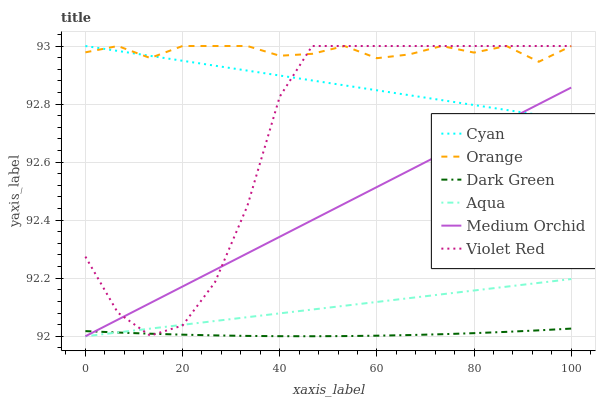Does Dark Green have the minimum area under the curve?
Answer yes or no. Yes. Does Orange have the maximum area under the curve?
Answer yes or no. Yes. Does Medium Orchid have the minimum area under the curve?
Answer yes or no. No. Does Medium Orchid have the maximum area under the curve?
Answer yes or no. No. Is Aqua the smoothest?
Answer yes or no. Yes. Is Violet Red the roughest?
Answer yes or no. Yes. Is Medium Orchid the smoothest?
Answer yes or no. No. Is Medium Orchid the roughest?
Answer yes or no. No. Does Medium Orchid have the lowest value?
Answer yes or no. Yes. Does Orange have the lowest value?
Answer yes or no. No. Does Cyan have the highest value?
Answer yes or no. Yes. Does Medium Orchid have the highest value?
Answer yes or no. No. Is Medium Orchid less than Orange?
Answer yes or no. Yes. Is Cyan greater than Dark Green?
Answer yes or no. Yes. Does Medium Orchid intersect Cyan?
Answer yes or no. Yes. Is Medium Orchid less than Cyan?
Answer yes or no. No. Is Medium Orchid greater than Cyan?
Answer yes or no. No. Does Medium Orchid intersect Orange?
Answer yes or no. No. 